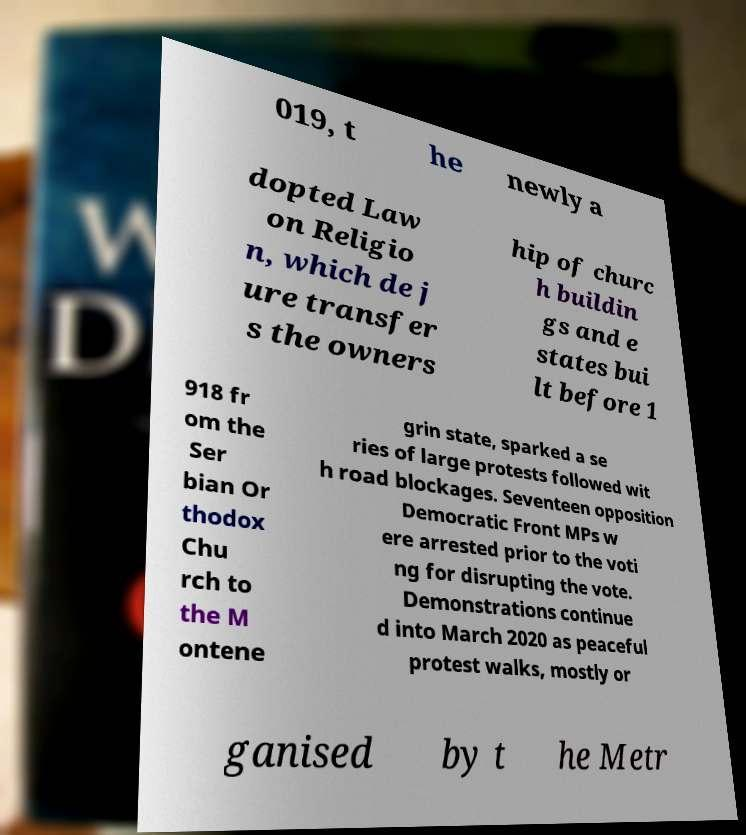I need the written content from this picture converted into text. Can you do that? 019, t he newly a dopted Law on Religio n, which de j ure transfer s the owners hip of churc h buildin gs and e states bui lt before 1 918 fr om the Ser bian Or thodox Chu rch to the M ontene grin state, sparked a se ries of large protests followed wit h road blockages. Seventeen opposition Democratic Front MPs w ere arrested prior to the voti ng for disrupting the vote. Demonstrations continue d into March 2020 as peaceful protest walks, mostly or ganised by t he Metr 